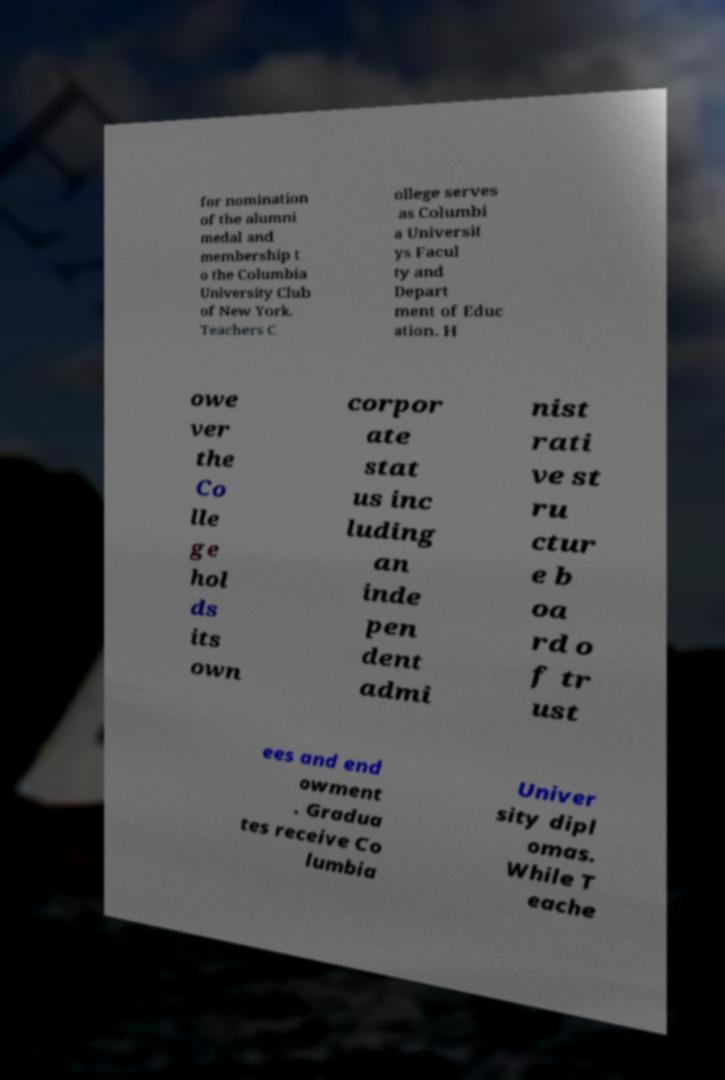Can you accurately transcribe the text from the provided image for me? for nomination of the alumni medal and membership t o the Columbia University Club of New York. Teachers C ollege serves as Columbi a Universit ys Facul ty and Depart ment of Educ ation. H owe ver the Co lle ge hol ds its own corpor ate stat us inc luding an inde pen dent admi nist rati ve st ru ctur e b oa rd o f tr ust ees and end owment . Gradua tes receive Co lumbia Univer sity dipl omas. While T eache 